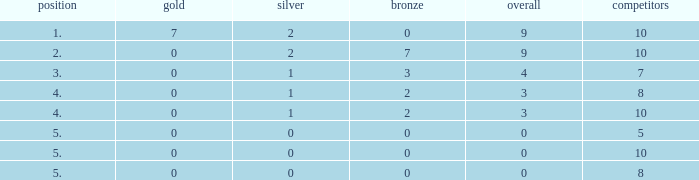What's the total Rank that has a Gold that's smaller than 0? None. 